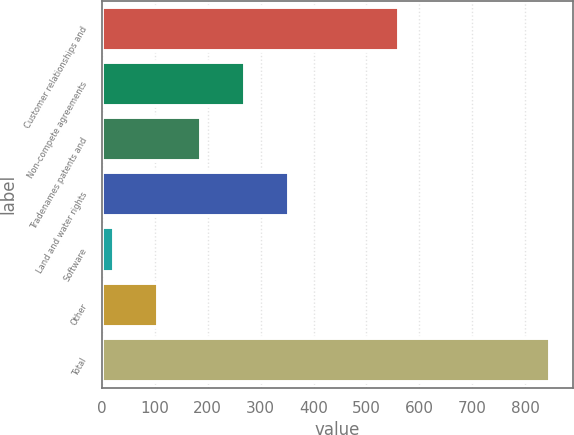<chart> <loc_0><loc_0><loc_500><loc_500><bar_chart><fcel>Customer relationships and<fcel>Non-compete agreements<fcel>Tradenames patents and<fcel>Land and water rights<fcel>Software<fcel>Other<fcel>Total<nl><fcel>561<fcel>270.5<fcel>188<fcel>353<fcel>23<fcel>105.5<fcel>848<nl></chart> 